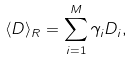<formula> <loc_0><loc_0><loc_500><loc_500>\langle D \rangle _ { R } = \sum _ { i = 1 } ^ { M } \gamma _ { i } D _ { i } ,</formula> 